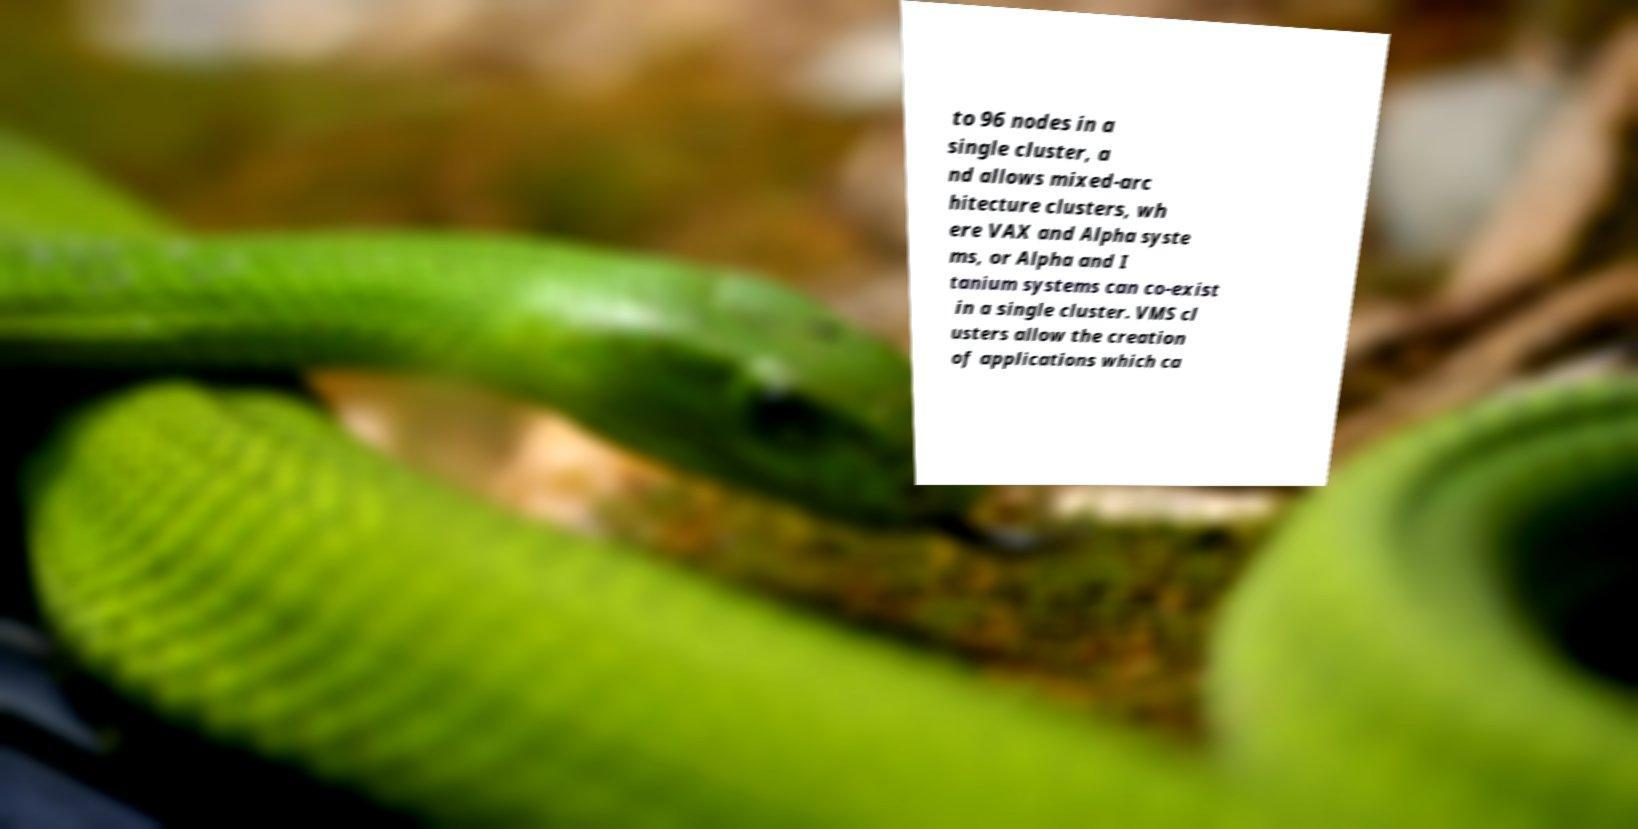There's text embedded in this image that I need extracted. Can you transcribe it verbatim? to 96 nodes in a single cluster, a nd allows mixed-arc hitecture clusters, wh ere VAX and Alpha syste ms, or Alpha and I tanium systems can co-exist in a single cluster. VMS cl usters allow the creation of applications which ca 